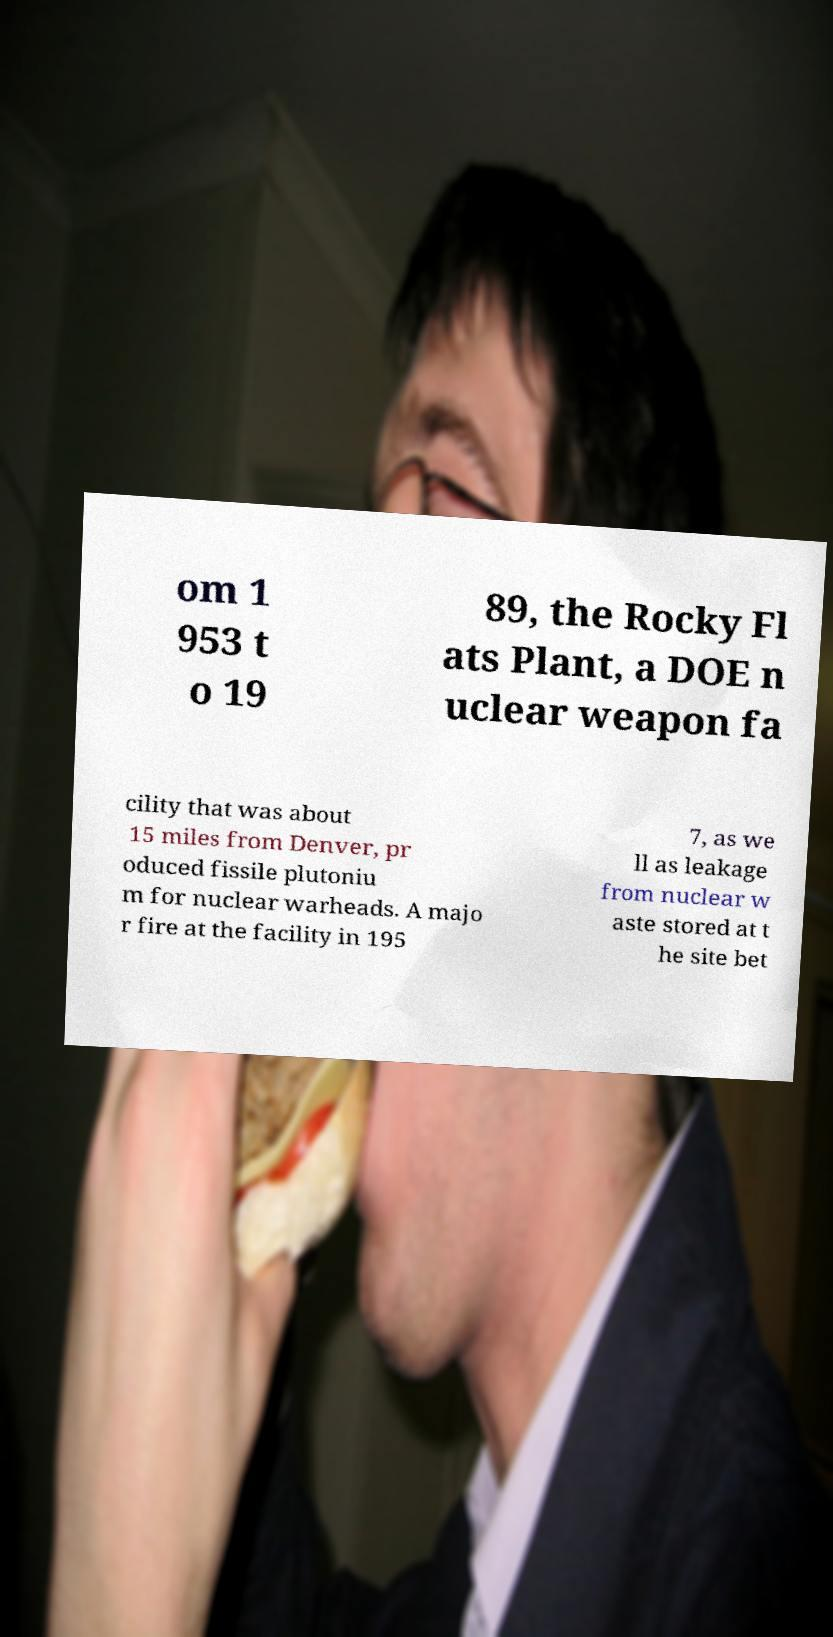Could you extract and type out the text from this image? om 1 953 t o 19 89, the Rocky Fl ats Plant, a DOE n uclear weapon fa cility that was about 15 miles from Denver, pr oduced fissile plutoniu m for nuclear warheads. A majo r fire at the facility in 195 7, as we ll as leakage from nuclear w aste stored at t he site bet 